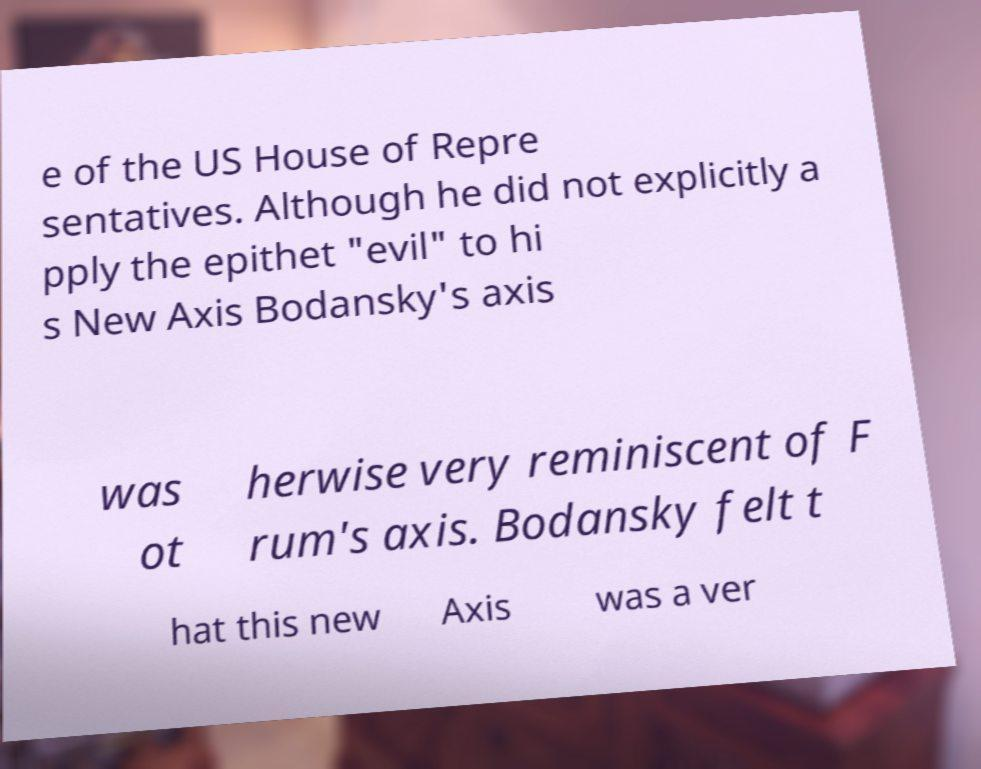What messages or text are displayed in this image? I need them in a readable, typed format. e of the US House of Repre sentatives. Although he did not explicitly a pply the epithet "evil" to hi s New Axis Bodansky's axis was ot herwise very reminiscent of F rum's axis. Bodansky felt t hat this new Axis was a ver 